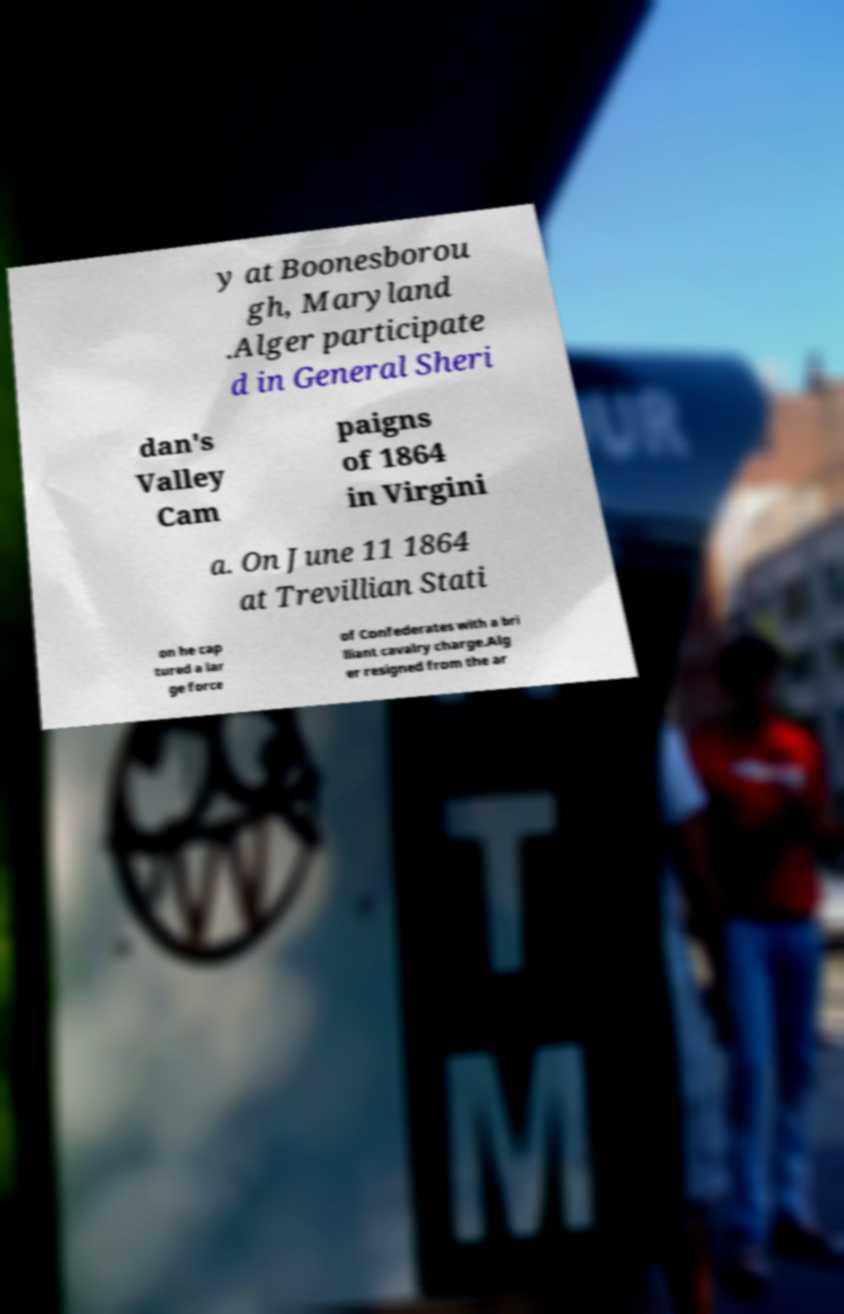Please read and relay the text visible in this image. What does it say? y at Boonesborou gh, Maryland .Alger participate d in General Sheri dan's Valley Cam paigns of 1864 in Virgini a. On June 11 1864 at Trevillian Stati on he cap tured a lar ge force of Confederates with a bri lliant cavalry charge.Alg er resigned from the ar 